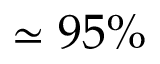Convert formula to latex. <formula><loc_0><loc_0><loc_500><loc_500>\simeq 9 5 \%</formula> 